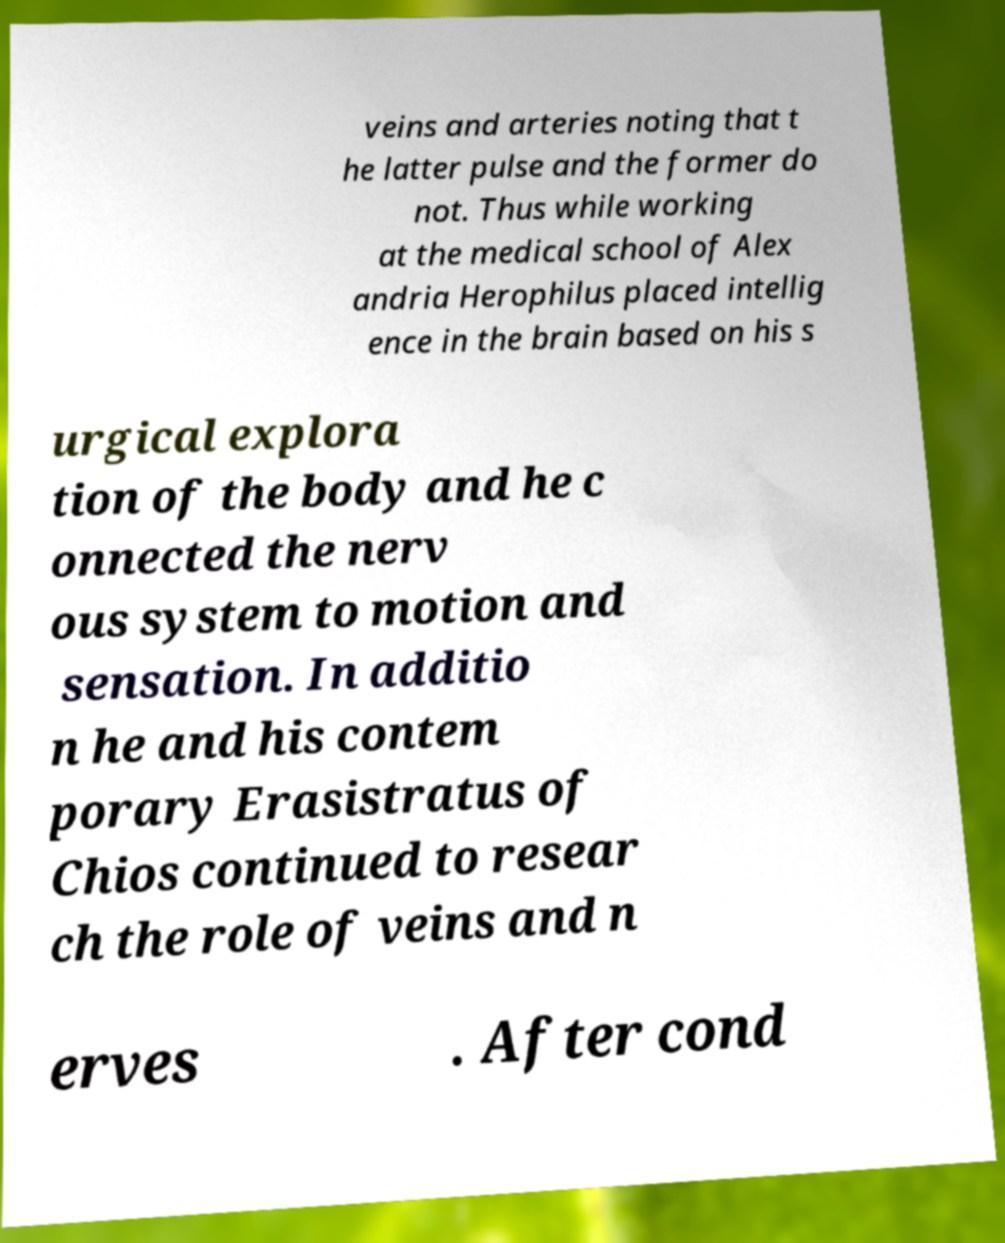Could you assist in decoding the text presented in this image and type it out clearly? veins and arteries noting that t he latter pulse and the former do not. Thus while working at the medical school of Alex andria Herophilus placed intellig ence in the brain based on his s urgical explora tion of the body and he c onnected the nerv ous system to motion and sensation. In additio n he and his contem porary Erasistratus of Chios continued to resear ch the role of veins and n erves . After cond 